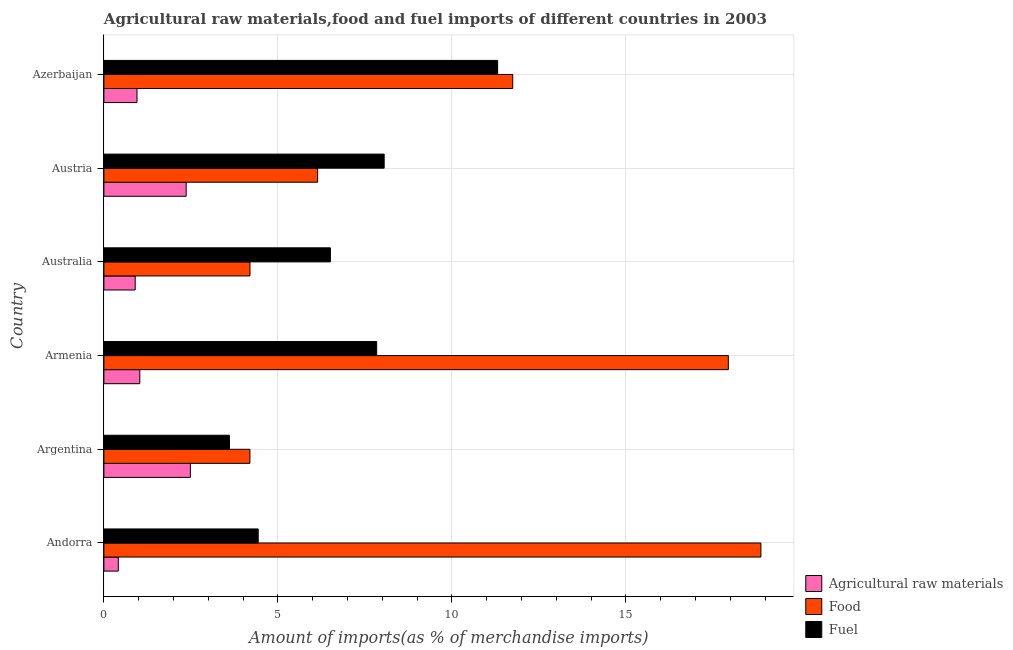How many different coloured bars are there?
Provide a short and direct response. 3. How many groups of bars are there?
Your response must be concise. 6. Are the number of bars per tick equal to the number of legend labels?
Provide a succinct answer. Yes. Are the number of bars on each tick of the Y-axis equal?
Give a very brief answer. Yes. How many bars are there on the 1st tick from the top?
Keep it short and to the point. 3. What is the label of the 4th group of bars from the top?
Offer a terse response. Armenia. What is the percentage of food imports in Argentina?
Offer a very short reply. 4.2. Across all countries, what is the maximum percentage of raw materials imports?
Your answer should be very brief. 2.48. Across all countries, what is the minimum percentage of food imports?
Provide a succinct answer. 4.2. In which country was the percentage of raw materials imports maximum?
Ensure brevity in your answer.  Argentina. In which country was the percentage of food imports minimum?
Your answer should be compact. Argentina. What is the total percentage of food imports in the graph?
Offer a very short reply. 63.11. What is the difference between the percentage of fuel imports in Armenia and that in Azerbaijan?
Offer a very short reply. -3.48. What is the difference between the percentage of raw materials imports in Australia and the percentage of fuel imports in Austria?
Give a very brief answer. -7.15. What is the average percentage of raw materials imports per country?
Your response must be concise. 1.36. What is the difference between the percentage of raw materials imports and percentage of food imports in Argentina?
Make the answer very short. -1.71. What is the ratio of the percentage of food imports in Armenia to that in Australia?
Offer a terse response. 4.27. What is the difference between the highest and the second highest percentage of raw materials imports?
Your answer should be very brief. 0.12. What is the difference between the highest and the lowest percentage of fuel imports?
Your response must be concise. 7.71. In how many countries, is the percentage of fuel imports greater than the average percentage of fuel imports taken over all countries?
Offer a very short reply. 3. What does the 2nd bar from the top in Andorra represents?
Keep it short and to the point. Food. What does the 2nd bar from the bottom in Azerbaijan represents?
Offer a very short reply. Food. How many bars are there?
Ensure brevity in your answer.  18. Are all the bars in the graph horizontal?
Provide a short and direct response. Yes. How many countries are there in the graph?
Provide a succinct answer. 6. What is the difference between two consecutive major ticks on the X-axis?
Keep it short and to the point. 5. Are the values on the major ticks of X-axis written in scientific E-notation?
Your answer should be very brief. No. Does the graph contain any zero values?
Provide a succinct answer. No. Does the graph contain grids?
Your answer should be very brief. Yes. Where does the legend appear in the graph?
Offer a terse response. Bottom right. How are the legend labels stacked?
Your answer should be very brief. Vertical. What is the title of the graph?
Your answer should be very brief. Agricultural raw materials,food and fuel imports of different countries in 2003. What is the label or title of the X-axis?
Your response must be concise. Amount of imports(as % of merchandise imports). What is the Amount of imports(as % of merchandise imports) of Agricultural raw materials in Andorra?
Your answer should be very brief. 0.41. What is the Amount of imports(as % of merchandise imports) in Food in Andorra?
Make the answer very short. 18.88. What is the Amount of imports(as % of merchandise imports) in Fuel in Andorra?
Provide a short and direct response. 4.43. What is the Amount of imports(as % of merchandise imports) in Agricultural raw materials in Argentina?
Your answer should be compact. 2.48. What is the Amount of imports(as % of merchandise imports) of Food in Argentina?
Your answer should be compact. 4.2. What is the Amount of imports(as % of merchandise imports) in Fuel in Argentina?
Offer a terse response. 3.61. What is the Amount of imports(as % of merchandise imports) in Agricultural raw materials in Armenia?
Offer a very short reply. 1.03. What is the Amount of imports(as % of merchandise imports) of Food in Armenia?
Offer a very short reply. 17.94. What is the Amount of imports(as % of merchandise imports) in Fuel in Armenia?
Ensure brevity in your answer.  7.84. What is the Amount of imports(as % of merchandise imports) of Agricultural raw materials in Australia?
Your answer should be very brief. 0.9. What is the Amount of imports(as % of merchandise imports) in Food in Australia?
Ensure brevity in your answer.  4.2. What is the Amount of imports(as % of merchandise imports) in Fuel in Australia?
Keep it short and to the point. 6.51. What is the Amount of imports(as % of merchandise imports) of Agricultural raw materials in Austria?
Your response must be concise. 2.36. What is the Amount of imports(as % of merchandise imports) of Food in Austria?
Your answer should be very brief. 6.14. What is the Amount of imports(as % of merchandise imports) in Fuel in Austria?
Offer a very short reply. 8.05. What is the Amount of imports(as % of merchandise imports) of Agricultural raw materials in Azerbaijan?
Your answer should be compact. 0.95. What is the Amount of imports(as % of merchandise imports) of Food in Azerbaijan?
Ensure brevity in your answer.  11.75. What is the Amount of imports(as % of merchandise imports) of Fuel in Azerbaijan?
Make the answer very short. 11.31. Across all countries, what is the maximum Amount of imports(as % of merchandise imports) of Agricultural raw materials?
Your response must be concise. 2.48. Across all countries, what is the maximum Amount of imports(as % of merchandise imports) in Food?
Keep it short and to the point. 18.88. Across all countries, what is the maximum Amount of imports(as % of merchandise imports) of Fuel?
Your answer should be very brief. 11.31. Across all countries, what is the minimum Amount of imports(as % of merchandise imports) in Agricultural raw materials?
Your answer should be very brief. 0.41. Across all countries, what is the minimum Amount of imports(as % of merchandise imports) in Food?
Your response must be concise. 4.2. Across all countries, what is the minimum Amount of imports(as % of merchandise imports) of Fuel?
Your answer should be compact. 3.61. What is the total Amount of imports(as % of merchandise imports) in Agricultural raw materials in the graph?
Make the answer very short. 8.15. What is the total Amount of imports(as % of merchandise imports) of Food in the graph?
Ensure brevity in your answer.  63.11. What is the total Amount of imports(as % of merchandise imports) in Fuel in the graph?
Make the answer very short. 41.76. What is the difference between the Amount of imports(as % of merchandise imports) of Agricultural raw materials in Andorra and that in Argentina?
Your response must be concise. -2.07. What is the difference between the Amount of imports(as % of merchandise imports) in Food in Andorra and that in Argentina?
Provide a short and direct response. 14.68. What is the difference between the Amount of imports(as % of merchandise imports) in Fuel in Andorra and that in Argentina?
Keep it short and to the point. 0.83. What is the difference between the Amount of imports(as % of merchandise imports) of Agricultural raw materials in Andorra and that in Armenia?
Ensure brevity in your answer.  -0.62. What is the difference between the Amount of imports(as % of merchandise imports) of Food in Andorra and that in Armenia?
Keep it short and to the point. 0.94. What is the difference between the Amount of imports(as % of merchandise imports) of Fuel in Andorra and that in Armenia?
Your answer should be compact. -3.4. What is the difference between the Amount of imports(as % of merchandise imports) in Agricultural raw materials in Andorra and that in Australia?
Provide a succinct answer. -0.49. What is the difference between the Amount of imports(as % of merchandise imports) in Food in Andorra and that in Australia?
Ensure brevity in your answer.  14.68. What is the difference between the Amount of imports(as % of merchandise imports) in Fuel in Andorra and that in Australia?
Ensure brevity in your answer.  -2.07. What is the difference between the Amount of imports(as % of merchandise imports) of Agricultural raw materials in Andorra and that in Austria?
Provide a succinct answer. -1.95. What is the difference between the Amount of imports(as % of merchandise imports) in Food in Andorra and that in Austria?
Make the answer very short. 12.74. What is the difference between the Amount of imports(as % of merchandise imports) of Fuel in Andorra and that in Austria?
Provide a succinct answer. -3.62. What is the difference between the Amount of imports(as % of merchandise imports) of Agricultural raw materials in Andorra and that in Azerbaijan?
Your response must be concise. -0.54. What is the difference between the Amount of imports(as % of merchandise imports) in Food in Andorra and that in Azerbaijan?
Keep it short and to the point. 7.13. What is the difference between the Amount of imports(as % of merchandise imports) in Fuel in Andorra and that in Azerbaijan?
Provide a short and direct response. -6.88. What is the difference between the Amount of imports(as % of merchandise imports) in Agricultural raw materials in Argentina and that in Armenia?
Make the answer very short. 1.45. What is the difference between the Amount of imports(as % of merchandise imports) of Food in Argentina and that in Armenia?
Offer a terse response. -13.75. What is the difference between the Amount of imports(as % of merchandise imports) in Fuel in Argentina and that in Armenia?
Give a very brief answer. -4.23. What is the difference between the Amount of imports(as % of merchandise imports) of Agricultural raw materials in Argentina and that in Australia?
Provide a short and direct response. 1.59. What is the difference between the Amount of imports(as % of merchandise imports) in Food in Argentina and that in Australia?
Offer a very short reply. -0. What is the difference between the Amount of imports(as % of merchandise imports) in Fuel in Argentina and that in Australia?
Your response must be concise. -2.9. What is the difference between the Amount of imports(as % of merchandise imports) in Agricultural raw materials in Argentina and that in Austria?
Keep it short and to the point. 0.12. What is the difference between the Amount of imports(as % of merchandise imports) of Food in Argentina and that in Austria?
Offer a very short reply. -1.95. What is the difference between the Amount of imports(as % of merchandise imports) of Fuel in Argentina and that in Austria?
Your answer should be very brief. -4.45. What is the difference between the Amount of imports(as % of merchandise imports) of Agricultural raw materials in Argentina and that in Azerbaijan?
Ensure brevity in your answer.  1.53. What is the difference between the Amount of imports(as % of merchandise imports) of Food in Argentina and that in Azerbaijan?
Keep it short and to the point. -7.55. What is the difference between the Amount of imports(as % of merchandise imports) in Fuel in Argentina and that in Azerbaijan?
Provide a short and direct response. -7.71. What is the difference between the Amount of imports(as % of merchandise imports) in Agricultural raw materials in Armenia and that in Australia?
Your answer should be very brief. 0.13. What is the difference between the Amount of imports(as % of merchandise imports) in Food in Armenia and that in Australia?
Your response must be concise. 13.75. What is the difference between the Amount of imports(as % of merchandise imports) in Fuel in Armenia and that in Australia?
Your answer should be compact. 1.33. What is the difference between the Amount of imports(as % of merchandise imports) in Agricultural raw materials in Armenia and that in Austria?
Ensure brevity in your answer.  -1.33. What is the difference between the Amount of imports(as % of merchandise imports) of Food in Armenia and that in Austria?
Your answer should be very brief. 11.8. What is the difference between the Amount of imports(as % of merchandise imports) of Fuel in Armenia and that in Austria?
Your answer should be compact. -0.22. What is the difference between the Amount of imports(as % of merchandise imports) of Agricultural raw materials in Armenia and that in Azerbaijan?
Keep it short and to the point. 0.08. What is the difference between the Amount of imports(as % of merchandise imports) in Food in Armenia and that in Azerbaijan?
Make the answer very short. 6.2. What is the difference between the Amount of imports(as % of merchandise imports) of Fuel in Armenia and that in Azerbaijan?
Provide a short and direct response. -3.48. What is the difference between the Amount of imports(as % of merchandise imports) in Agricultural raw materials in Australia and that in Austria?
Provide a short and direct response. -1.46. What is the difference between the Amount of imports(as % of merchandise imports) in Food in Australia and that in Austria?
Give a very brief answer. -1.94. What is the difference between the Amount of imports(as % of merchandise imports) in Fuel in Australia and that in Austria?
Your response must be concise. -1.55. What is the difference between the Amount of imports(as % of merchandise imports) in Agricultural raw materials in Australia and that in Azerbaijan?
Keep it short and to the point. -0.05. What is the difference between the Amount of imports(as % of merchandise imports) of Food in Australia and that in Azerbaijan?
Keep it short and to the point. -7.55. What is the difference between the Amount of imports(as % of merchandise imports) of Fuel in Australia and that in Azerbaijan?
Offer a very short reply. -4.81. What is the difference between the Amount of imports(as % of merchandise imports) in Agricultural raw materials in Austria and that in Azerbaijan?
Give a very brief answer. 1.41. What is the difference between the Amount of imports(as % of merchandise imports) in Food in Austria and that in Azerbaijan?
Your answer should be compact. -5.61. What is the difference between the Amount of imports(as % of merchandise imports) of Fuel in Austria and that in Azerbaijan?
Offer a terse response. -3.26. What is the difference between the Amount of imports(as % of merchandise imports) of Agricultural raw materials in Andorra and the Amount of imports(as % of merchandise imports) of Food in Argentina?
Offer a terse response. -3.78. What is the difference between the Amount of imports(as % of merchandise imports) of Agricultural raw materials in Andorra and the Amount of imports(as % of merchandise imports) of Fuel in Argentina?
Offer a terse response. -3.19. What is the difference between the Amount of imports(as % of merchandise imports) of Food in Andorra and the Amount of imports(as % of merchandise imports) of Fuel in Argentina?
Offer a very short reply. 15.27. What is the difference between the Amount of imports(as % of merchandise imports) of Agricultural raw materials in Andorra and the Amount of imports(as % of merchandise imports) of Food in Armenia?
Your answer should be very brief. -17.53. What is the difference between the Amount of imports(as % of merchandise imports) of Agricultural raw materials in Andorra and the Amount of imports(as % of merchandise imports) of Fuel in Armenia?
Make the answer very short. -7.42. What is the difference between the Amount of imports(as % of merchandise imports) of Food in Andorra and the Amount of imports(as % of merchandise imports) of Fuel in Armenia?
Offer a terse response. 11.04. What is the difference between the Amount of imports(as % of merchandise imports) of Agricultural raw materials in Andorra and the Amount of imports(as % of merchandise imports) of Food in Australia?
Provide a short and direct response. -3.78. What is the difference between the Amount of imports(as % of merchandise imports) of Agricultural raw materials in Andorra and the Amount of imports(as % of merchandise imports) of Fuel in Australia?
Offer a terse response. -6.09. What is the difference between the Amount of imports(as % of merchandise imports) of Food in Andorra and the Amount of imports(as % of merchandise imports) of Fuel in Australia?
Your answer should be very brief. 12.37. What is the difference between the Amount of imports(as % of merchandise imports) in Agricultural raw materials in Andorra and the Amount of imports(as % of merchandise imports) in Food in Austria?
Offer a very short reply. -5.73. What is the difference between the Amount of imports(as % of merchandise imports) of Agricultural raw materials in Andorra and the Amount of imports(as % of merchandise imports) of Fuel in Austria?
Provide a succinct answer. -7.64. What is the difference between the Amount of imports(as % of merchandise imports) of Food in Andorra and the Amount of imports(as % of merchandise imports) of Fuel in Austria?
Ensure brevity in your answer.  10.83. What is the difference between the Amount of imports(as % of merchandise imports) in Agricultural raw materials in Andorra and the Amount of imports(as % of merchandise imports) in Food in Azerbaijan?
Provide a succinct answer. -11.33. What is the difference between the Amount of imports(as % of merchandise imports) in Agricultural raw materials in Andorra and the Amount of imports(as % of merchandise imports) in Fuel in Azerbaijan?
Make the answer very short. -10.9. What is the difference between the Amount of imports(as % of merchandise imports) of Food in Andorra and the Amount of imports(as % of merchandise imports) of Fuel in Azerbaijan?
Your response must be concise. 7.57. What is the difference between the Amount of imports(as % of merchandise imports) of Agricultural raw materials in Argentina and the Amount of imports(as % of merchandise imports) of Food in Armenia?
Your answer should be compact. -15.46. What is the difference between the Amount of imports(as % of merchandise imports) in Agricultural raw materials in Argentina and the Amount of imports(as % of merchandise imports) in Fuel in Armenia?
Offer a terse response. -5.35. What is the difference between the Amount of imports(as % of merchandise imports) of Food in Argentina and the Amount of imports(as % of merchandise imports) of Fuel in Armenia?
Make the answer very short. -3.64. What is the difference between the Amount of imports(as % of merchandise imports) of Agricultural raw materials in Argentina and the Amount of imports(as % of merchandise imports) of Food in Australia?
Provide a succinct answer. -1.71. What is the difference between the Amount of imports(as % of merchandise imports) in Agricultural raw materials in Argentina and the Amount of imports(as % of merchandise imports) in Fuel in Australia?
Provide a short and direct response. -4.02. What is the difference between the Amount of imports(as % of merchandise imports) of Food in Argentina and the Amount of imports(as % of merchandise imports) of Fuel in Australia?
Offer a terse response. -2.31. What is the difference between the Amount of imports(as % of merchandise imports) of Agricultural raw materials in Argentina and the Amount of imports(as % of merchandise imports) of Food in Austria?
Your answer should be compact. -3.66. What is the difference between the Amount of imports(as % of merchandise imports) of Agricultural raw materials in Argentina and the Amount of imports(as % of merchandise imports) of Fuel in Austria?
Ensure brevity in your answer.  -5.57. What is the difference between the Amount of imports(as % of merchandise imports) in Food in Argentina and the Amount of imports(as % of merchandise imports) in Fuel in Austria?
Provide a succinct answer. -3.86. What is the difference between the Amount of imports(as % of merchandise imports) of Agricultural raw materials in Argentina and the Amount of imports(as % of merchandise imports) of Food in Azerbaijan?
Provide a succinct answer. -9.26. What is the difference between the Amount of imports(as % of merchandise imports) of Agricultural raw materials in Argentina and the Amount of imports(as % of merchandise imports) of Fuel in Azerbaijan?
Your answer should be very brief. -8.83. What is the difference between the Amount of imports(as % of merchandise imports) in Food in Argentina and the Amount of imports(as % of merchandise imports) in Fuel in Azerbaijan?
Your answer should be compact. -7.12. What is the difference between the Amount of imports(as % of merchandise imports) of Agricultural raw materials in Armenia and the Amount of imports(as % of merchandise imports) of Food in Australia?
Give a very brief answer. -3.17. What is the difference between the Amount of imports(as % of merchandise imports) in Agricultural raw materials in Armenia and the Amount of imports(as % of merchandise imports) in Fuel in Australia?
Your answer should be compact. -5.48. What is the difference between the Amount of imports(as % of merchandise imports) of Food in Armenia and the Amount of imports(as % of merchandise imports) of Fuel in Australia?
Provide a short and direct response. 11.44. What is the difference between the Amount of imports(as % of merchandise imports) of Agricultural raw materials in Armenia and the Amount of imports(as % of merchandise imports) of Food in Austria?
Your answer should be compact. -5.11. What is the difference between the Amount of imports(as % of merchandise imports) of Agricultural raw materials in Armenia and the Amount of imports(as % of merchandise imports) of Fuel in Austria?
Provide a short and direct response. -7.02. What is the difference between the Amount of imports(as % of merchandise imports) of Food in Armenia and the Amount of imports(as % of merchandise imports) of Fuel in Austria?
Your response must be concise. 9.89. What is the difference between the Amount of imports(as % of merchandise imports) of Agricultural raw materials in Armenia and the Amount of imports(as % of merchandise imports) of Food in Azerbaijan?
Make the answer very short. -10.72. What is the difference between the Amount of imports(as % of merchandise imports) in Agricultural raw materials in Armenia and the Amount of imports(as % of merchandise imports) in Fuel in Azerbaijan?
Ensure brevity in your answer.  -10.28. What is the difference between the Amount of imports(as % of merchandise imports) in Food in Armenia and the Amount of imports(as % of merchandise imports) in Fuel in Azerbaijan?
Your response must be concise. 6.63. What is the difference between the Amount of imports(as % of merchandise imports) of Agricultural raw materials in Australia and the Amount of imports(as % of merchandise imports) of Food in Austria?
Provide a succinct answer. -5.24. What is the difference between the Amount of imports(as % of merchandise imports) in Agricultural raw materials in Australia and the Amount of imports(as % of merchandise imports) in Fuel in Austria?
Offer a very short reply. -7.15. What is the difference between the Amount of imports(as % of merchandise imports) of Food in Australia and the Amount of imports(as % of merchandise imports) of Fuel in Austria?
Make the answer very short. -3.86. What is the difference between the Amount of imports(as % of merchandise imports) of Agricultural raw materials in Australia and the Amount of imports(as % of merchandise imports) of Food in Azerbaijan?
Keep it short and to the point. -10.85. What is the difference between the Amount of imports(as % of merchandise imports) of Agricultural raw materials in Australia and the Amount of imports(as % of merchandise imports) of Fuel in Azerbaijan?
Offer a terse response. -10.41. What is the difference between the Amount of imports(as % of merchandise imports) in Food in Australia and the Amount of imports(as % of merchandise imports) in Fuel in Azerbaijan?
Offer a very short reply. -7.12. What is the difference between the Amount of imports(as % of merchandise imports) of Agricultural raw materials in Austria and the Amount of imports(as % of merchandise imports) of Food in Azerbaijan?
Provide a short and direct response. -9.38. What is the difference between the Amount of imports(as % of merchandise imports) in Agricultural raw materials in Austria and the Amount of imports(as % of merchandise imports) in Fuel in Azerbaijan?
Keep it short and to the point. -8.95. What is the difference between the Amount of imports(as % of merchandise imports) in Food in Austria and the Amount of imports(as % of merchandise imports) in Fuel in Azerbaijan?
Ensure brevity in your answer.  -5.17. What is the average Amount of imports(as % of merchandise imports) of Agricultural raw materials per country?
Give a very brief answer. 1.36. What is the average Amount of imports(as % of merchandise imports) of Food per country?
Provide a succinct answer. 10.52. What is the average Amount of imports(as % of merchandise imports) in Fuel per country?
Offer a very short reply. 6.96. What is the difference between the Amount of imports(as % of merchandise imports) of Agricultural raw materials and Amount of imports(as % of merchandise imports) of Food in Andorra?
Give a very brief answer. -18.47. What is the difference between the Amount of imports(as % of merchandise imports) in Agricultural raw materials and Amount of imports(as % of merchandise imports) in Fuel in Andorra?
Offer a very short reply. -4.02. What is the difference between the Amount of imports(as % of merchandise imports) in Food and Amount of imports(as % of merchandise imports) in Fuel in Andorra?
Ensure brevity in your answer.  14.45. What is the difference between the Amount of imports(as % of merchandise imports) of Agricultural raw materials and Amount of imports(as % of merchandise imports) of Food in Argentina?
Keep it short and to the point. -1.71. What is the difference between the Amount of imports(as % of merchandise imports) of Agricultural raw materials and Amount of imports(as % of merchandise imports) of Fuel in Argentina?
Offer a very short reply. -1.12. What is the difference between the Amount of imports(as % of merchandise imports) of Food and Amount of imports(as % of merchandise imports) of Fuel in Argentina?
Give a very brief answer. 0.59. What is the difference between the Amount of imports(as % of merchandise imports) of Agricultural raw materials and Amount of imports(as % of merchandise imports) of Food in Armenia?
Ensure brevity in your answer.  -16.91. What is the difference between the Amount of imports(as % of merchandise imports) in Agricultural raw materials and Amount of imports(as % of merchandise imports) in Fuel in Armenia?
Offer a very short reply. -6.81. What is the difference between the Amount of imports(as % of merchandise imports) in Food and Amount of imports(as % of merchandise imports) in Fuel in Armenia?
Offer a terse response. 10.11. What is the difference between the Amount of imports(as % of merchandise imports) of Agricultural raw materials and Amount of imports(as % of merchandise imports) of Food in Australia?
Your answer should be compact. -3.3. What is the difference between the Amount of imports(as % of merchandise imports) of Agricultural raw materials and Amount of imports(as % of merchandise imports) of Fuel in Australia?
Your response must be concise. -5.61. What is the difference between the Amount of imports(as % of merchandise imports) of Food and Amount of imports(as % of merchandise imports) of Fuel in Australia?
Give a very brief answer. -2.31. What is the difference between the Amount of imports(as % of merchandise imports) of Agricultural raw materials and Amount of imports(as % of merchandise imports) of Food in Austria?
Your response must be concise. -3.78. What is the difference between the Amount of imports(as % of merchandise imports) in Agricultural raw materials and Amount of imports(as % of merchandise imports) in Fuel in Austria?
Keep it short and to the point. -5.69. What is the difference between the Amount of imports(as % of merchandise imports) in Food and Amount of imports(as % of merchandise imports) in Fuel in Austria?
Provide a succinct answer. -1.91. What is the difference between the Amount of imports(as % of merchandise imports) in Agricultural raw materials and Amount of imports(as % of merchandise imports) in Food in Azerbaijan?
Ensure brevity in your answer.  -10.8. What is the difference between the Amount of imports(as % of merchandise imports) of Agricultural raw materials and Amount of imports(as % of merchandise imports) of Fuel in Azerbaijan?
Offer a very short reply. -10.36. What is the difference between the Amount of imports(as % of merchandise imports) in Food and Amount of imports(as % of merchandise imports) in Fuel in Azerbaijan?
Provide a succinct answer. 0.43. What is the ratio of the Amount of imports(as % of merchandise imports) in Agricultural raw materials in Andorra to that in Argentina?
Keep it short and to the point. 0.17. What is the ratio of the Amount of imports(as % of merchandise imports) of Food in Andorra to that in Argentina?
Keep it short and to the point. 4.5. What is the ratio of the Amount of imports(as % of merchandise imports) of Fuel in Andorra to that in Argentina?
Your answer should be compact. 1.23. What is the ratio of the Amount of imports(as % of merchandise imports) of Agricultural raw materials in Andorra to that in Armenia?
Provide a short and direct response. 0.4. What is the ratio of the Amount of imports(as % of merchandise imports) of Food in Andorra to that in Armenia?
Offer a very short reply. 1.05. What is the ratio of the Amount of imports(as % of merchandise imports) of Fuel in Andorra to that in Armenia?
Provide a short and direct response. 0.57. What is the ratio of the Amount of imports(as % of merchandise imports) in Agricultural raw materials in Andorra to that in Australia?
Offer a very short reply. 0.46. What is the ratio of the Amount of imports(as % of merchandise imports) of Food in Andorra to that in Australia?
Offer a terse response. 4.5. What is the ratio of the Amount of imports(as % of merchandise imports) in Fuel in Andorra to that in Australia?
Offer a very short reply. 0.68. What is the ratio of the Amount of imports(as % of merchandise imports) in Agricultural raw materials in Andorra to that in Austria?
Keep it short and to the point. 0.18. What is the ratio of the Amount of imports(as % of merchandise imports) of Food in Andorra to that in Austria?
Offer a terse response. 3.07. What is the ratio of the Amount of imports(as % of merchandise imports) of Fuel in Andorra to that in Austria?
Keep it short and to the point. 0.55. What is the ratio of the Amount of imports(as % of merchandise imports) of Agricultural raw materials in Andorra to that in Azerbaijan?
Ensure brevity in your answer.  0.44. What is the ratio of the Amount of imports(as % of merchandise imports) of Food in Andorra to that in Azerbaijan?
Provide a succinct answer. 1.61. What is the ratio of the Amount of imports(as % of merchandise imports) of Fuel in Andorra to that in Azerbaijan?
Give a very brief answer. 0.39. What is the ratio of the Amount of imports(as % of merchandise imports) in Agricultural raw materials in Argentina to that in Armenia?
Your answer should be compact. 2.41. What is the ratio of the Amount of imports(as % of merchandise imports) of Food in Argentina to that in Armenia?
Offer a terse response. 0.23. What is the ratio of the Amount of imports(as % of merchandise imports) of Fuel in Argentina to that in Armenia?
Provide a short and direct response. 0.46. What is the ratio of the Amount of imports(as % of merchandise imports) in Agricultural raw materials in Argentina to that in Australia?
Your answer should be very brief. 2.76. What is the ratio of the Amount of imports(as % of merchandise imports) in Food in Argentina to that in Australia?
Give a very brief answer. 1. What is the ratio of the Amount of imports(as % of merchandise imports) of Fuel in Argentina to that in Australia?
Ensure brevity in your answer.  0.55. What is the ratio of the Amount of imports(as % of merchandise imports) of Agricultural raw materials in Argentina to that in Austria?
Provide a succinct answer. 1.05. What is the ratio of the Amount of imports(as % of merchandise imports) of Food in Argentina to that in Austria?
Provide a succinct answer. 0.68. What is the ratio of the Amount of imports(as % of merchandise imports) in Fuel in Argentina to that in Austria?
Your response must be concise. 0.45. What is the ratio of the Amount of imports(as % of merchandise imports) of Agricultural raw materials in Argentina to that in Azerbaijan?
Offer a terse response. 2.61. What is the ratio of the Amount of imports(as % of merchandise imports) in Food in Argentina to that in Azerbaijan?
Offer a very short reply. 0.36. What is the ratio of the Amount of imports(as % of merchandise imports) of Fuel in Argentina to that in Azerbaijan?
Provide a succinct answer. 0.32. What is the ratio of the Amount of imports(as % of merchandise imports) in Agricultural raw materials in Armenia to that in Australia?
Your answer should be compact. 1.15. What is the ratio of the Amount of imports(as % of merchandise imports) in Food in Armenia to that in Australia?
Make the answer very short. 4.27. What is the ratio of the Amount of imports(as % of merchandise imports) of Fuel in Armenia to that in Australia?
Ensure brevity in your answer.  1.2. What is the ratio of the Amount of imports(as % of merchandise imports) in Agricultural raw materials in Armenia to that in Austria?
Your answer should be very brief. 0.44. What is the ratio of the Amount of imports(as % of merchandise imports) of Food in Armenia to that in Austria?
Keep it short and to the point. 2.92. What is the ratio of the Amount of imports(as % of merchandise imports) in Fuel in Armenia to that in Austria?
Offer a very short reply. 0.97. What is the ratio of the Amount of imports(as % of merchandise imports) in Agricultural raw materials in Armenia to that in Azerbaijan?
Ensure brevity in your answer.  1.08. What is the ratio of the Amount of imports(as % of merchandise imports) of Food in Armenia to that in Azerbaijan?
Your answer should be very brief. 1.53. What is the ratio of the Amount of imports(as % of merchandise imports) of Fuel in Armenia to that in Azerbaijan?
Provide a succinct answer. 0.69. What is the ratio of the Amount of imports(as % of merchandise imports) of Agricultural raw materials in Australia to that in Austria?
Give a very brief answer. 0.38. What is the ratio of the Amount of imports(as % of merchandise imports) in Food in Australia to that in Austria?
Offer a very short reply. 0.68. What is the ratio of the Amount of imports(as % of merchandise imports) in Fuel in Australia to that in Austria?
Give a very brief answer. 0.81. What is the ratio of the Amount of imports(as % of merchandise imports) of Agricultural raw materials in Australia to that in Azerbaijan?
Offer a terse response. 0.95. What is the ratio of the Amount of imports(as % of merchandise imports) in Food in Australia to that in Azerbaijan?
Ensure brevity in your answer.  0.36. What is the ratio of the Amount of imports(as % of merchandise imports) in Fuel in Australia to that in Azerbaijan?
Keep it short and to the point. 0.58. What is the ratio of the Amount of imports(as % of merchandise imports) in Agricultural raw materials in Austria to that in Azerbaijan?
Provide a succinct answer. 2.48. What is the ratio of the Amount of imports(as % of merchandise imports) of Food in Austria to that in Azerbaijan?
Offer a terse response. 0.52. What is the ratio of the Amount of imports(as % of merchandise imports) in Fuel in Austria to that in Azerbaijan?
Offer a terse response. 0.71. What is the difference between the highest and the second highest Amount of imports(as % of merchandise imports) of Agricultural raw materials?
Your answer should be compact. 0.12. What is the difference between the highest and the second highest Amount of imports(as % of merchandise imports) in Food?
Your answer should be very brief. 0.94. What is the difference between the highest and the second highest Amount of imports(as % of merchandise imports) of Fuel?
Make the answer very short. 3.26. What is the difference between the highest and the lowest Amount of imports(as % of merchandise imports) in Agricultural raw materials?
Offer a very short reply. 2.07. What is the difference between the highest and the lowest Amount of imports(as % of merchandise imports) in Food?
Give a very brief answer. 14.68. What is the difference between the highest and the lowest Amount of imports(as % of merchandise imports) in Fuel?
Your response must be concise. 7.71. 